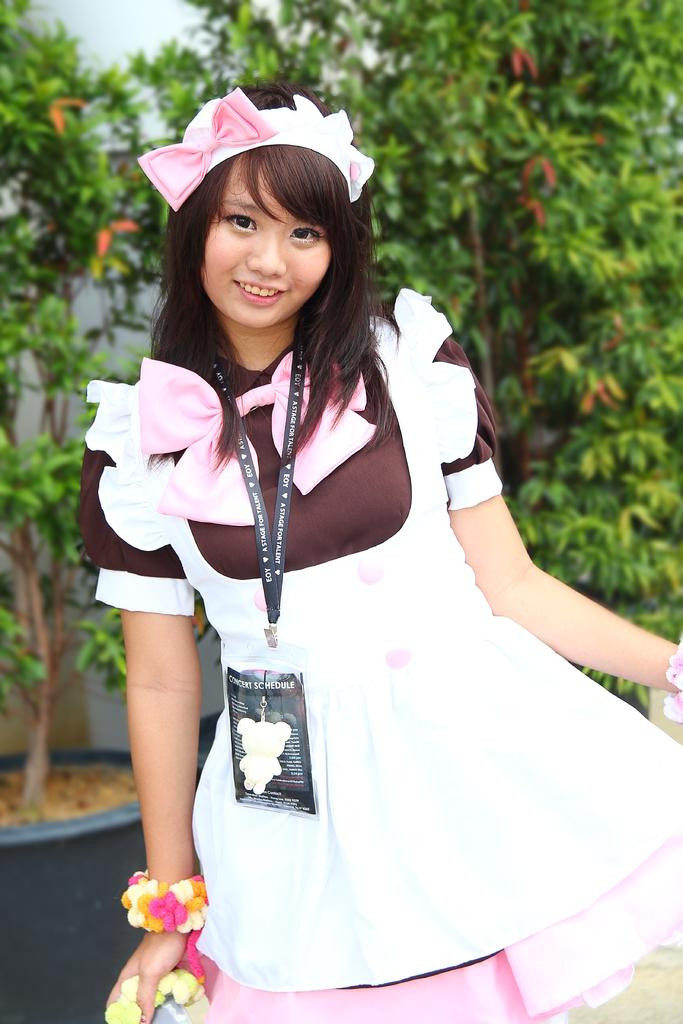Who is the main subject in the image? There is a girl in the image. What is the girl doing in the image? The girl is standing. What can be seen around the girl's neck? The girl has an ID card around her neck. What is the girl holding in her hand? The girl is holding an object in her hand. What can be seen in the background of the image? There are plants and a wall in the background of the image. What type of corn can be seen growing on the hill in the image? There is no corn or hill present in the image. How many clams can be seen on the wall in the image? There are no clams present in the image; the wall is a background element without any visible objects on it. 